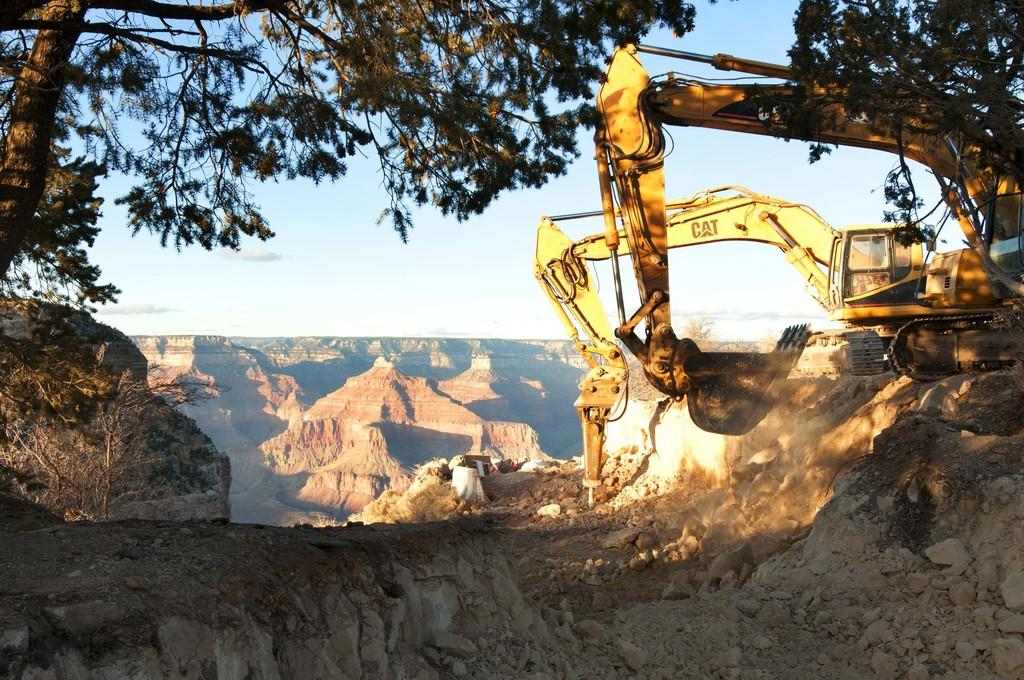What type of natural elements can be seen in the front of the image? There are stones in the front of the image. What is happening to the stones in the center of the image? Vehicles are crushing the stones in the center of the image. What type of landscape can be seen in the background of the image? There are mountains in the background of the image. What other natural elements can be seen in the center of the image? There are trees in the center of the image. Where is the arm holding the pot on the stove in the image? There is no arm, pot, or stove present in the image. What type of stove is used to cook the food in the image? There is no stove or food present in the image. 